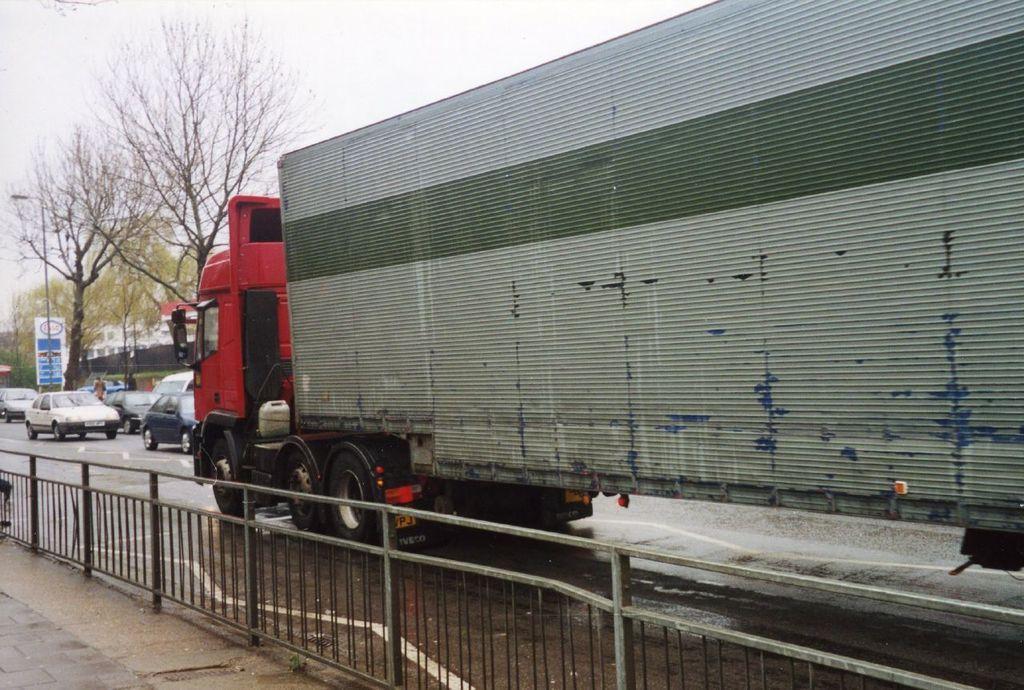Please provide a concise description of this image. In this image I can see a vehicle in red and gray color. I can also see few vehicles on the road, railing, trees in green color and sky in white color. 